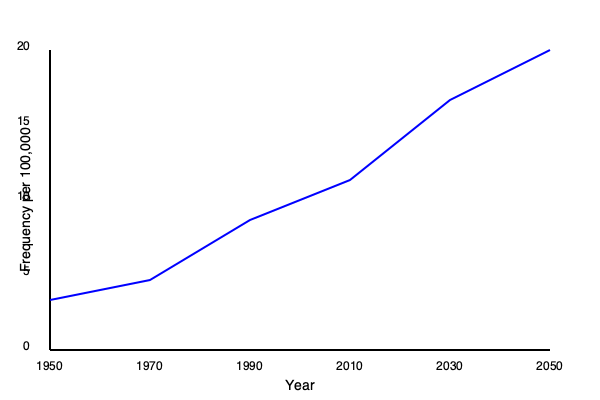Analyze the line graph depicting the frequency of the Yanos surname over time. Calculate the average rate of change in the surname's frequency per decade between 1950 and 2050, expressed as a change in occurrences per 100,000 people. To calculate the average rate of change per decade:

1. Determine total change:
   Start (1950): ~3.5 per 100,000
   End (2050): ~19 per 100,000
   Total change: 19 - 3.5 = 15.5 per 100,000

2. Calculate time span:
   2050 - 1950 = 100 years = 10 decades

3. Compute average change per decade:
   $\frac{\text{Total change}}{\text{Number of decades}} = \frac{15.5}{10} = 1.55$ per 100,000

Therefore, the average rate of change is 1.55 occurrences per 100,000 people per decade.
Answer: 1.55 per 100,000 per decade 